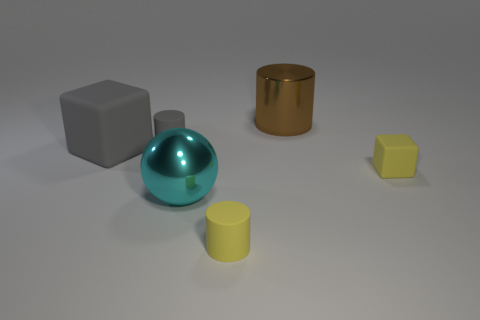Subtract 1 balls. How many balls are left? 0 Subtract all small matte cylinders. How many cylinders are left? 1 Add 5 big purple metal balls. How many big purple metal balls exist? 5 Add 3 yellow blocks. How many objects exist? 9 Subtract all brown cylinders. How many cylinders are left? 2 Subtract 0 red cylinders. How many objects are left? 6 Subtract all spheres. How many objects are left? 5 Subtract all blue spheres. Subtract all brown blocks. How many spheres are left? 1 Subtract all yellow balls. How many yellow blocks are left? 1 Subtract all matte cylinders. Subtract all large gray rubber cubes. How many objects are left? 3 